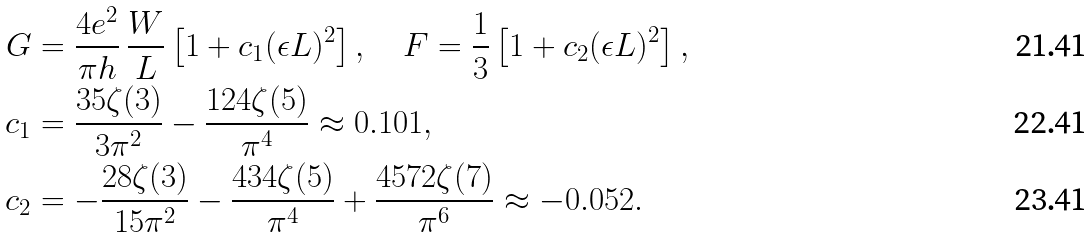Convert formula to latex. <formula><loc_0><loc_0><loc_500><loc_500>G & = \frac { 4 e ^ { 2 } } { \pi h } \, \frac { W } { L } \left [ 1 + c _ { 1 } ( \epsilon L ) ^ { 2 } \right ] , \quad F = \frac { 1 } { 3 } \left [ 1 + c _ { 2 } ( \epsilon L ) ^ { 2 } \right ] , \\ c _ { 1 } & = \frac { 3 5 \zeta ( 3 ) } { 3 \pi ^ { 2 } } - \frac { 1 2 4 \zeta ( 5 ) } { \pi ^ { 4 } } \approx 0 . 1 0 1 , \\ c _ { 2 } & = - \frac { 2 8 \zeta ( 3 ) } { 1 5 \pi ^ { 2 } } - \frac { 4 3 4 \zeta ( 5 ) } { \pi ^ { 4 } } + \frac { 4 5 7 2 \zeta ( 7 ) } { \pi ^ { 6 } } \approx - 0 . 0 5 2 .</formula> 